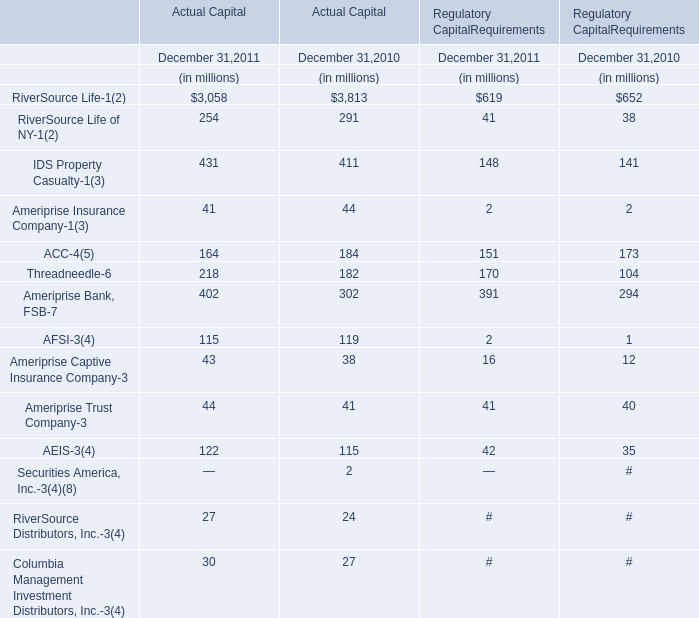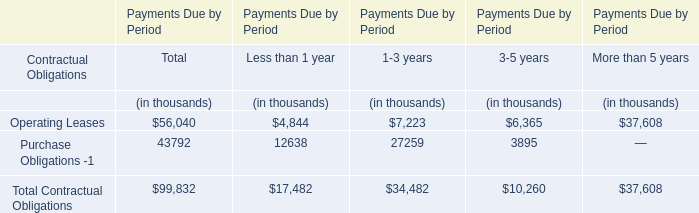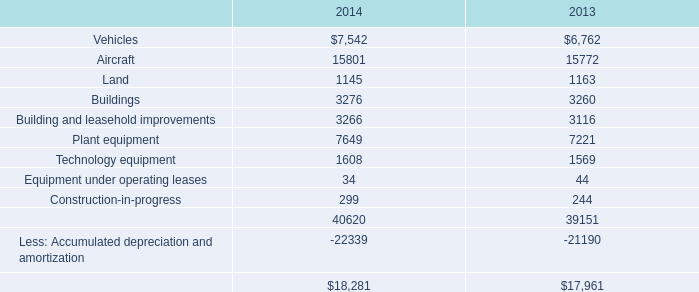What will IDS Property Casualty of Actual Capital be like in 2012 if it continues to grow at the same rate as it did in 2011? (in millions) 
Computations: ((1 + ((431 - 411) / 411)) * 431)
Answer: 451.97324. 